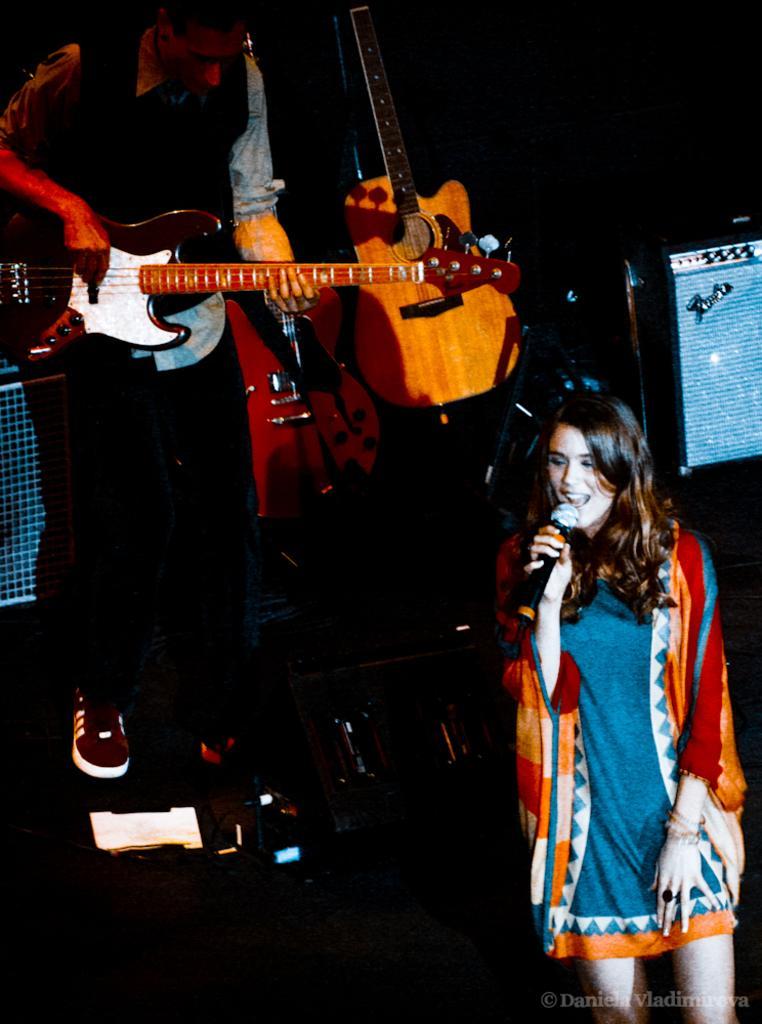Could you give a brief overview of what you see in this image? This woman is singing in-front of mic. This man is playing guitar. 